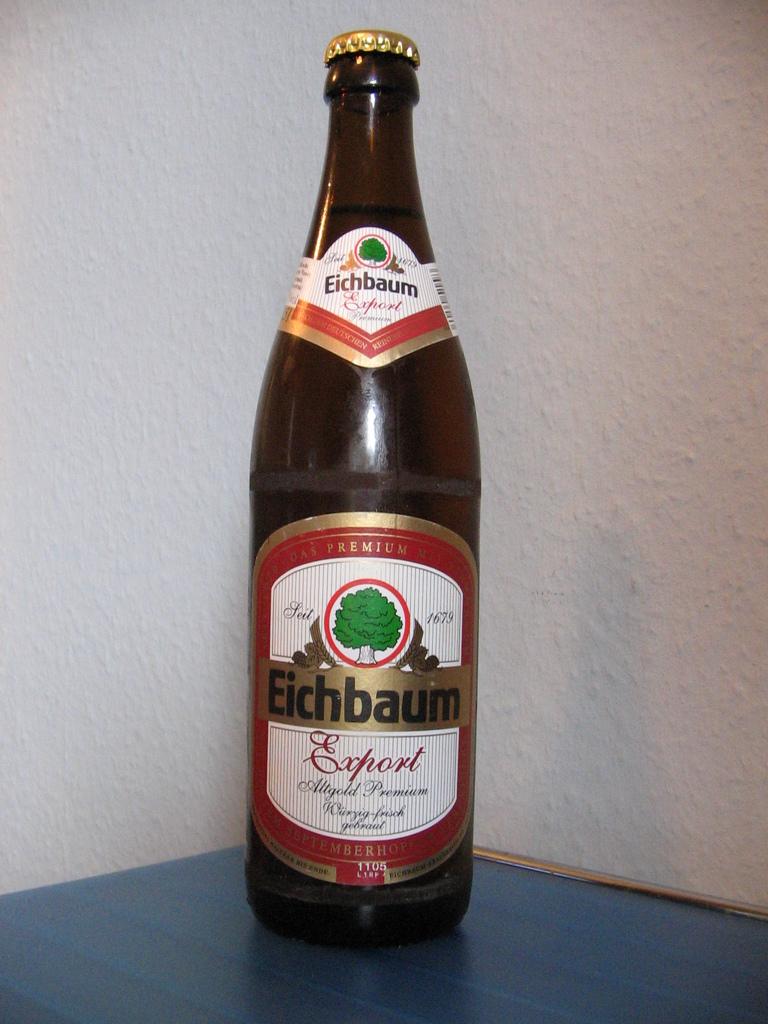What type of beer is it?
Ensure brevity in your answer.  Eichbaum. What year is on the label?
Your response must be concise. 1679. 